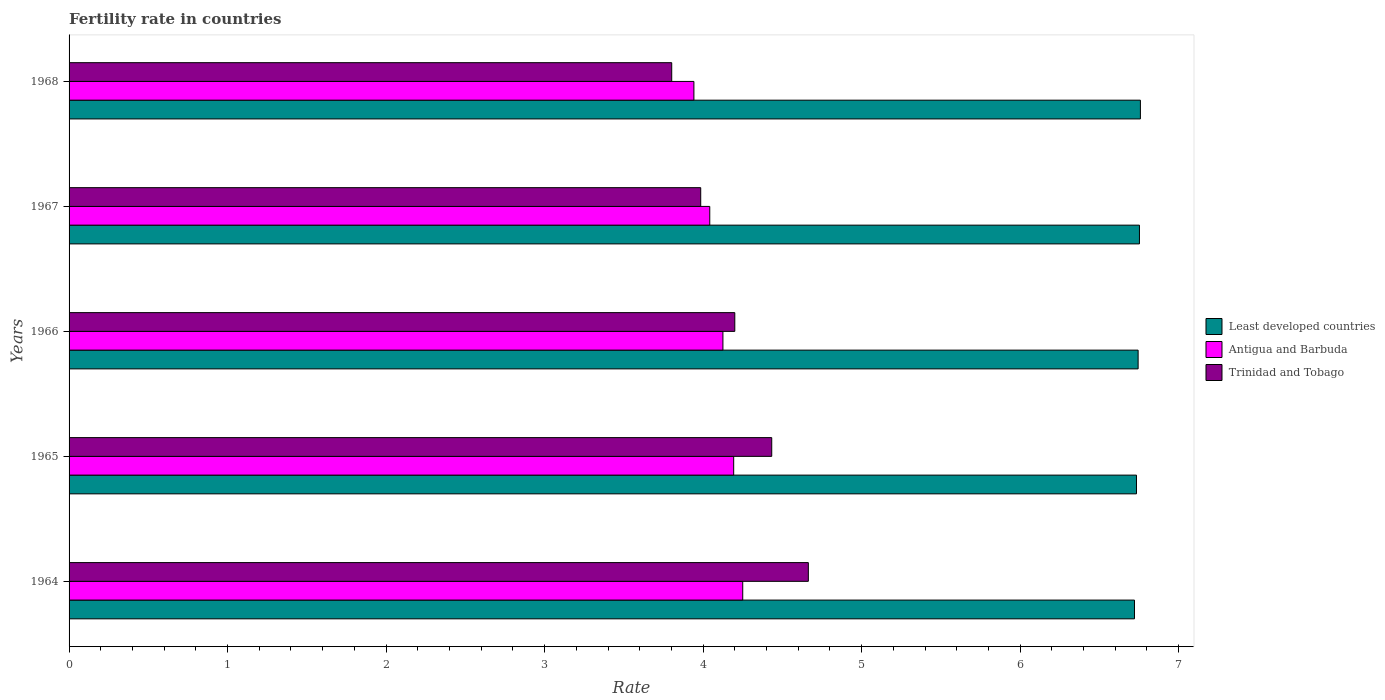How many different coloured bars are there?
Offer a terse response. 3. How many groups of bars are there?
Provide a short and direct response. 5. How many bars are there on the 3rd tick from the top?
Keep it short and to the point. 3. What is the label of the 4th group of bars from the top?
Give a very brief answer. 1965. What is the fertility rate in Trinidad and Tobago in 1964?
Offer a terse response. 4.66. Across all years, what is the maximum fertility rate in Least developed countries?
Ensure brevity in your answer.  6.76. Across all years, what is the minimum fertility rate in Trinidad and Tobago?
Offer a terse response. 3.8. In which year was the fertility rate in Antigua and Barbuda maximum?
Offer a terse response. 1964. In which year was the fertility rate in Trinidad and Tobago minimum?
Your answer should be very brief. 1968. What is the total fertility rate in Antigua and Barbuda in the graph?
Offer a terse response. 20.55. What is the difference between the fertility rate in Least developed countries in 1967 and that in 1968?
Your answer should be very brief. -0.01. What is the difference between the fertility rate in Antigua and Barbuda in 1964 and the fertility rate in Trinidad and Tobago in 1967?
Your answer should be very brief. 0.27. What is the average fertility rate in Least developed countries per year?
Your answer should be compact. 6.74. In the year 1966, what is the difference between the fertility rate in Antigua and Barbuda and fertility rate in Least developed countries?
Give a very brief answer. -2.62. What is the ratio of the fertility rate in Antigua and Barbuda in 1965 to that in 1966?
Offer a terse response. 1.02. What is the difference between the highest and the second highest fertility rate in Antigua and Barbuda?
Your response must be concise. 0.06. What is the difference between the highest and the lowest fertility rate in Trinidad and Tobago?
Provide a short and direct response. 0.86. Is the sum of the fertility rate in Antigua and Barbuda in 1964 and 1965 greater than the maximum fertility rate in Least developed countries across all years?
Your response must be concise. Yes. What does the 3rd bar from the top in 1967 represents?
Make the answer very short. Least developed countries. What does the 3rd bar from the bottom in 1966 represents?
Your response must be concise. Trinidad and Tobago. How many years are there in the graph?
Your answer should be very brief. 5. What is the difference between two consecutive major ticks on the X-axis?
Keep it short and to the point. 1. Does the graph contain any zero values?
Your answer should be very brief. No. Does the graph contain grids?
Give a very brief answer. No. What is the title of the graph?
Your answer should be compact. Fertility rate in countries. What is the label or title of the X-axis?
Offer a very short reply. Rate. What is the label or title of the Y-axis?
Your answer should be compact. Years. What is the Rate of Least developed countries in 1964?
Offer a terse response. 6.72. What is the Rate of Antigua and Barbuda in 1964?
Keep it short and to the point. 4.25. What is the Rate in Trinidad and Tobago in 1964?
Your answer should be very brief. 4.66. What is the Rate in Least developed countries in 1965?
Offer a terse response. 6.73. What is the Rate of Antigua and Barbuda in 1965?
Your answer should be very brief. 4.19. What is the Rate in Trinidad and Tobago in 1965?
Offer a terse response. 4.43. What is the Rate of Least developed countries in 1966?
Make the answer very short. 6.74. What is the Rate in Antigua and Barbuda in 1966?
Provide a succinct answer. 4.12. What is the Rate of Least developed countries in 1967?
Keep it short and to the point. 6.75. What is the Rate in Antigua and Barbuda in 1967?
Keep it short and to the point. 4.04. What is the Rate of Trinidad and Tobago in 1967?
Ensure brevity in your answer.  3.98. What is the Rate in Least developed countries in 1968?
Give a very brief answer. 6.76. What is the Rate in Antigua and Barbuda in 1968?
Make the answer very short. 3.94. What is the Rate in Trinidad and Tobago in 1968?
Provide a succinct answer. 3.8. Across all years, what is the maximum Rate of Least developed countries?
Offer a terse response. 6.76. Across all years, what is the maximum Rate of Antigua and Barbuda?
Your answer should be very brief. 4.25. Across all years, what is the maximum Rate in Trinidad and Tobago?
Keep it short and to the point. 4.66. Across all years, what is the minimum Rate of Least developed countries?
Provide a succinct answer. 6.72. Across all years, what is the minimum Rate in Antigua and Barbuda?
Make the answer very short. 3.94. Across all years, what is the minimum Rate in Trinidad and Tobago?
Your answer should be compact. 3.8. What is the total Rate in Least developed countries in the graph?
Provide a short and direct response. 33.71. What is the total Rate of Antigua and Barbuda in the graph?
Your answer should be compact. 20.55. What is the total Rate in Trinidad and Tobago in the graph?
Your answer should be compact. 21.08. What is the difference between the Rate in Least developed countries in 1964 and that in 1965?
Offer a terse response. -0.01. What is the difference between the Rate in Antigua and Barbuda in 1964 and that in 1965?
Make the answer very short. 0.06. What is the difference between the Rate of Trinidad and Tobago in 1964 and that in 1965?
Provide a succinct answer. 0.23. What is the difference between the Rate of Least developed countries in 1964 and that in 1966?
Make the answer very short. -0.02. What is the difference between the Rate in Antigua and Barbuda in 1964 and that in 1966?
Keep it short and to the point. 0.12. What is the difference between the Rate of Trinidad and Tobago in 1964 and that in 1966?
Your answer should be compact. 0.46. What is the difference between the Rate in Least developed countries in 1964 and that in 1967?
Give a very brief answer. -0.03. What is the difference between the Rate in Antigua and Barbuda in 1964 and that in 1967?
Offer a terse response. 0.21. What is the difference between the Rate in Trinidad and Tobago in 1964 and that in 1967?
Your answer should be compact. 0.68. What is the difference between the Rate in Least developed countries in 1964 and that in 1968?
Give a very brief answer. -0.04. What is the difference between the Rate in Antigua and Barbuda in 1964 and that in 1968?
Keep it short and to the point. 0.31. What is the difference between the Rate of Trinidad and Tobago in 1964 and that in 1968?
Keep it short and to the point. 0.86. What is the difference between the Rate of Least developed countries in 1965 and that in 1966?
Provide a short and direct response. -0.01. What is the difference between the Rate in Antigua and Barbuda in 1965 and that in 1966?
Your answer should be very brief. 0.07. What is the difference between the Rate of Trinidad and Tobago in 1965 and that in 1966?
Ensure brevity in your answer.  0.23. What is the difference between the Rate in Least developed countries in 1965 and that in 1967?
Keep it short and to the point. -0.02. What is the difference between the Rate of Antigua and Barbuda in 1965 and that in 1967?
Your response must be concise. 0.15. What is the difference between the Rate in Trinidad and Tobago in 1965 and that in 1967?
Your answer should be very brief. 0.45. What is the difference between the Rate of Least developed countries in 1965 and that in 1968?
Offer a very short reply. -0.02. What is the difference between the Rate in Antigua and Barbuda in 1965 and that in 1968?
Offer a terse response. 0.25. What is the difference between the Rate of Trinidad and Tobago in 1965 and that in 1968?
Keep it short and to the point. 0.63. What is the difference between the Rate of Least developed countries in 1966 and that in 1967?
Your answer should be very brief. -0.01. What is the difference between the Rate in Antigua and Barbuda in 1966 and that in 1967?
Your answer should be compact. 0.08. What is the difference between the Rate in Trinidad and Tobago in 1966 and that in 1967?
Ensure brevity in your answer.  0.21. What is the difference between the Rate of Least developed countries in 1966 and that in 1968?
Provide a succinct answer. -0.01. What is the difference between the Rate in Antigua and Barbuda in 1966 and that in 1968?
Provide a short and direct response. 0.18. What is the difference between the Rate of Trinidad and Tobago in 1966 and that in 1968?
Give a very brief answer. 0.4. What is the difference between the Rate of Least developed countries in 1967 and that in 1968?
Ensure brevity in your answer.  -0.01. What is the difference between the Rate in Antigua and Barbuda in 1967 and that in 1968?
Offer a terse response. 0.1. What is the difference between the Rate of Trinidad and Tobago in 1967 and that in 1968?
Your answer should be very brief. 0.18. What is the difference between the Rate in Least developed countries in 1964 and the Rate in Antigua and Barbuda in 1965?
Your answer should be very brief. 2.53. What is the difference between the Rate of Least developed countries in 1964 and the Rate of Trinidad and Tobago in 1965?
Provide a short and direct response. 2.29. What is the difference between the Rate in Antigua and Barbuda in 1964 and the Rate in Trinidad and Tobago in 1965?
Your answer should be very brief. -0.18. What is the difference between the Rate of Least developed countries in 1964 and the Rate of Antigua and Barbuda in 1966?
Ensure brevity in your answer.  2.6. What is the difference between the Rate in Least developed countries in 1964 and the Rate in Trinidad and Tobago in 1966?
Your answer should be compact. 2.52. What is the difference between the Rate in Least developed countries in 1964 and the Rate in Antigua and Barbuda in 1967?
Give a very brief answer. 2.68. What is the difference between the Rate of Least developed countries in 1964 and the Rate of Trinidad and Tobago in 1967?
Your answer should be very brief. 2.74. What is the difference between the Rate in Antigua and Barbuda in 1964 and the Rate in Trinidad and Tobago in 1967?
Offer a terse response. 0.27. What is the difference between the Rate in Least developed countries in 1964 and the Rate in Antigua and Barbuda in 1968?
Give a very brief answer. 2.78. What is the difference between the Rate in Least developed countries in 1964 and the Rate in Trinidad and Tobago in 1968?
Your answer should be compact. 2.92. What is the difference between the Rate of Antigua and Barbuda in 1964 and the Rate of Trinidad and Tobago in 1968?
Provide a succinct answer. 0.45. What is the difference between the Rate in Least developed countries in 1965 and the Rate in Antigua and Barbuda in 1966?
Make the answer very short. 2.61. What is the difference between the Rate in Least developed countries in 1965 and the Rate in Trinidad and Tobago in 1966?
Your answer should be very brief. 2.53. What is the difference between the Rate of Antigua and Barbuda in 1965 and the Rate of Trinidad and Tobago in 1966?
Give a very brief answer. -0.01. What is the difference between the Rate in Least developed countries in 1965 and the Rate in Antigua and Barbuda in 1967?
Provide a succinct answer. 2.69. What is the difference between the Rate of Least developed countries in 1965 and the Rate of Trinidad and Tobago in 1967?
Your answer should be compact. 2.75. What is the difference between the Rate in Antigua and Barbuda in 1965 and the Rate in Trinidad and Tobago in 1967?
Offer a terse response. 0.21. What is the difference between the Rate in Least developed countries in 1965 and the Rate in Antigua and Barbuda in 1968?
Offer a very short reply. 2.79. What is the difference between the Rate of Least developed countries in 1965 and the Rate of Trinidad and Tobago in 1968?
Your response must be concise. 2.93. What is the difference between the Rate of Antigua and Barbuda in 1965 and the Rate of Trinidad and Tobago in 1968?
Make the answer very short. 0.39. What is the difference between the Rate of Least developed countries in 1966 and the Rate of Antigua and Barbuda in 1967?
Your response must be concise. 2.7. What is the difference between the Rate in Least developed countries in 1966 and the Rate in Trinidad and Tobago in 1967?
Provide a succinct answer. 2.76. What is the difference between the Rate in Antigua and Barbuda in 1966 and the Rate in Trinidad and Tobago in 1967?
Your answer should be compact. 0.14. What is the difference between the Rate in Least developed countries in 1966 and the Rate in Antigua and Barbuda in 1968?
Provide a short and direct response. 2.8. What is the difference between the Rate of Least developed countries in 1966 and the Rate of Trinidad and Tobago in 1968?
Your response must be concise. 2.94. What is the difference between the Rate of Antigua and Barbuda in 1966 and the Rate of Trinidad and Tobago in 1968?
Give a very brief answer. 0.32. What is the difference between the Rate of Least developed countries in 1967 and the Rate of Antigua and Barbuda in 1968?
Make the answer very short. 2.81. What is the difference between the Rate in Least developed countries in 1967 and the Rate in Trinidad and Tobago in 1968?
Provide a short and direct response. 2.95. What is the difference between the Rate in Antigua and Barbuda in 1967 and the Rate in Trinidad and Tobago in 1968?
Make the answer very short. 0.24. What is the average Rate in Least developed countries per year?
Ensure brevity in your answer.  6.74. What is the average Rate of Antigua and Barbuda per year?
Make the answer very short. 4.11. What is the average Rate of Trinidad and Tobago per year?
Give a very brief answer. 4.22. In the year 1964, what is the difference between the Rate of Least developed countries and Rate of Antigua and Barbuda?
Offer a very short reply. 2.47. In the year 1964, what is the difference between the Rate of Least developed countries and Rate of Trinidad and Tobago?
Provide a succinct answer. 2.06. In the year 1964, what is the difference between the Rate of Antigua and Barbuda and Rate of Trinidad and Tobago?
Give a very brief answer. -0.41. In the year 1965, what is the difference between the Rate of Least developed countries and Rate of Antigua and Barbuda?
Ensure brevity in your answer.  2.54. In the year 1965, what is the difference between the Rate of Least developed countries and Rate of Trinidad and Tobago?
Keep it short and to the point. 2.3. In the year 1965, what is the difference between the Rate in Antigua and Barbuda and Rate in Trinidad and Tobago?
Give a very brief answer. -0.24. In the year 1966, what is the difference between the Rate of Least developed countries and Rate of Antigua and Barbuda?
Provide a short and direct response. 2.62. In the year 1966, what is the difference between the Rate of Least developed countries and Rate of Trinidad and Tobago?
Your response must be concise. 2.54. In the year 1966, what is the difference between the Rate of Antigua and Barbuda and Rate of Trinidad and Tobago?
Keep it short and to the point. -0.07. In the year 1967, what is the difference between the Rate of Least developed countries and Rate of Antigua and Barbuda?
Offer a very short reply. 2.71. In the year 1967, what is the difference between the Rate of Least developed countries and Rate of Trinidad and Tobago?
Keep it short and to the point. 2.77. In the year 1967, what is the difference between the Rate of Antigua and Barbuda and Rate of Trinidad and Tobago?
Your answer should be very brief. 0.06. In the year 1968, what is the difference between the Rate of Least developed countries and Rate of Antigua and Barbuda?
Provide a succinct answer. 2.82. In the year 1968, what is the difference between the Rate of Least developed countries and Rate of Trinidad and Tobago?
Provide a succinct answer. 2.96. In the year 1968, what is the difference between the Rate in Antigua and Barbuda and Rate in Trinidad and Tobago?
Keep it short and to the point. 0.14. What is the ratio of the Rate of Least developed countries in 1964 to that in 1965?
Provide a succinct answer. 1. What is the ratio of the Rate of Antigua and Barbuda in 1964 to that in 1965?
Give a very brief answer. 1.01. What is the ratio of the Rate of Trinidad and Tobago in 1964 to that in 1965?
Your answer should be very brief. 1.05. What is the ratio of the Rate of Least developed countries in 1964 to that in 1966?
Keep it short and to the point. 1. What is the ratio of the Rate of Antigua and Barbuda in 1964 to that in 1966?
Your answer should be very brief. 1.03. What is the ratio of the Rate in Trinidad and Tobago in 1964 to that in 1966?
Give a very brief answer. 1.11. What is the ratio of the Rate of Antigua and Barbuda in 1964 to that in 1967?
Provide a short and direct response. 1.05. What is the ratio of the Rate in Trinidad and Tobago in 1964 to that in 1967?
Ensure brevity in your answer.  1.17. What is the ratio of the Rate of Least developed countries in 1964 to that in 1968?
Ensure brevity in your answer.  0.99. What is the ratio of the Rate of Antigua and Barbuda in 1964 to that in 1968?
Keep it short and to the point. 1.08. What is the ratio of the Rate in Trinidad and Tobago in 1964 to that in 1968?
Give a very brief answer. 1.23. What is the ratio of the Rate in Antigua and Barbuda in 1965 to that in 1966?
Offer a very short reply. 1.02. What is the ratio of the Rate in Trinidad and Tobago in 1965 to that in 1966?
Ensure brevity in your answer.  1.06. What is the ratio of the Rate of Antigua and Barbuda in 1965 to that in 1967?
Provide a succinct answer. 1.04. What is the ratio of the Rate in Trinidad and Tobago in 1965 to that in 1967?
Ensure brevity in your answer.  1.11. What is the ratio of the Rate of Least developed countries in 1965 to that in 1968?
Give a very brief answer. 1. What is the ratio of the Rate of Antigua and Barbuda in 1965 to that in 1968?
Ensure brevity in your answer.  1.06. What is the ratio of the Rate in Trinidad and Tobago in 1965 to that in 1968?
Give a very brief answer. 1.17. What is the ratio of the Rate in Least developed countries in 1966 to that in 1967?
Provide a succinct answer. 1. What is the ratio of the Rate in Antigua and Barbuda in 1966 to that in 1967?
Your answer should be compact. 1.02. What is the ratio of the Rate of Trinidad and Tobago in 1966 to that in 1967?
Offer a very short reply. 1.05. What is the ratio of the Rate of Antigua and Barbuda in 1966 to that in 1968?
Offer a terse response. 1.05. What is the ratio of the Rate of Trinidad and Tobago in 1966 to that in 1968?
Your answer should be very brief. 1.1. What is the ratio of the Rate of Antigua and Barbuda in 1967 to that in 1968?
Offer a terse response. 1.03. What is the ratio of the Rate in Trinidad and Tobago in 1967 to that in 1968?
Your answer should be very brief. 1.05. What is the difference between the highest and the second highest Rate in Least developed countries?
Give a very brief answer. 0.01. What is the difference between the highest and the second highest Rate in Antigua and Barbuda?
Your answer should be compact. 0.06. What is the difference between the highest and the second highest Rate in Trinidad and Tobago?
Make the answer very short. 0.23. What is the difference between the highest and the lowest Rate in Least developed countries?
Provide a short and direct response. 0.04. What is the difference between the highest and the lowest Rate in Antigua and Barbuda?
Make the answer very short. 0.31. What is the difference between the highest and the lowest Rate in Trinidad and Tobago?
Your response must be concise. 0.86. 